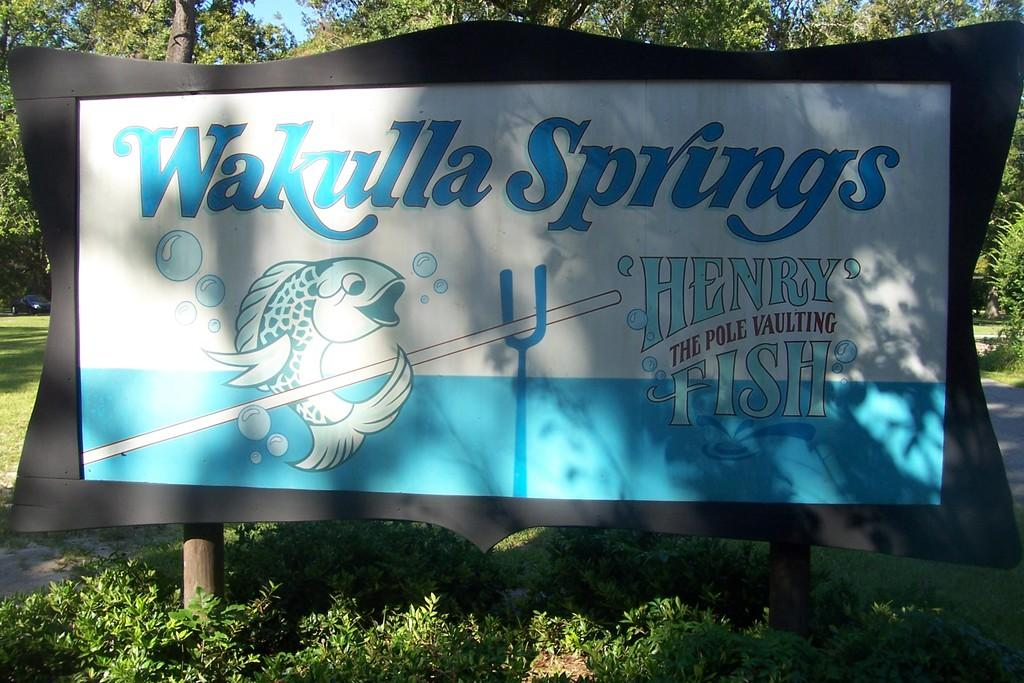What is the main object in the center of the image? There is a board in the center of the image. What can be seen at the bottom of the image? There are plants at the bottom of the image. What is visible in the background of the image? There are trees, grass, and a car in the background of the image. What type of toothpaste is being used to clean the board in the image? There is no toothpaste present in the image, and the board is not being cleaned. 